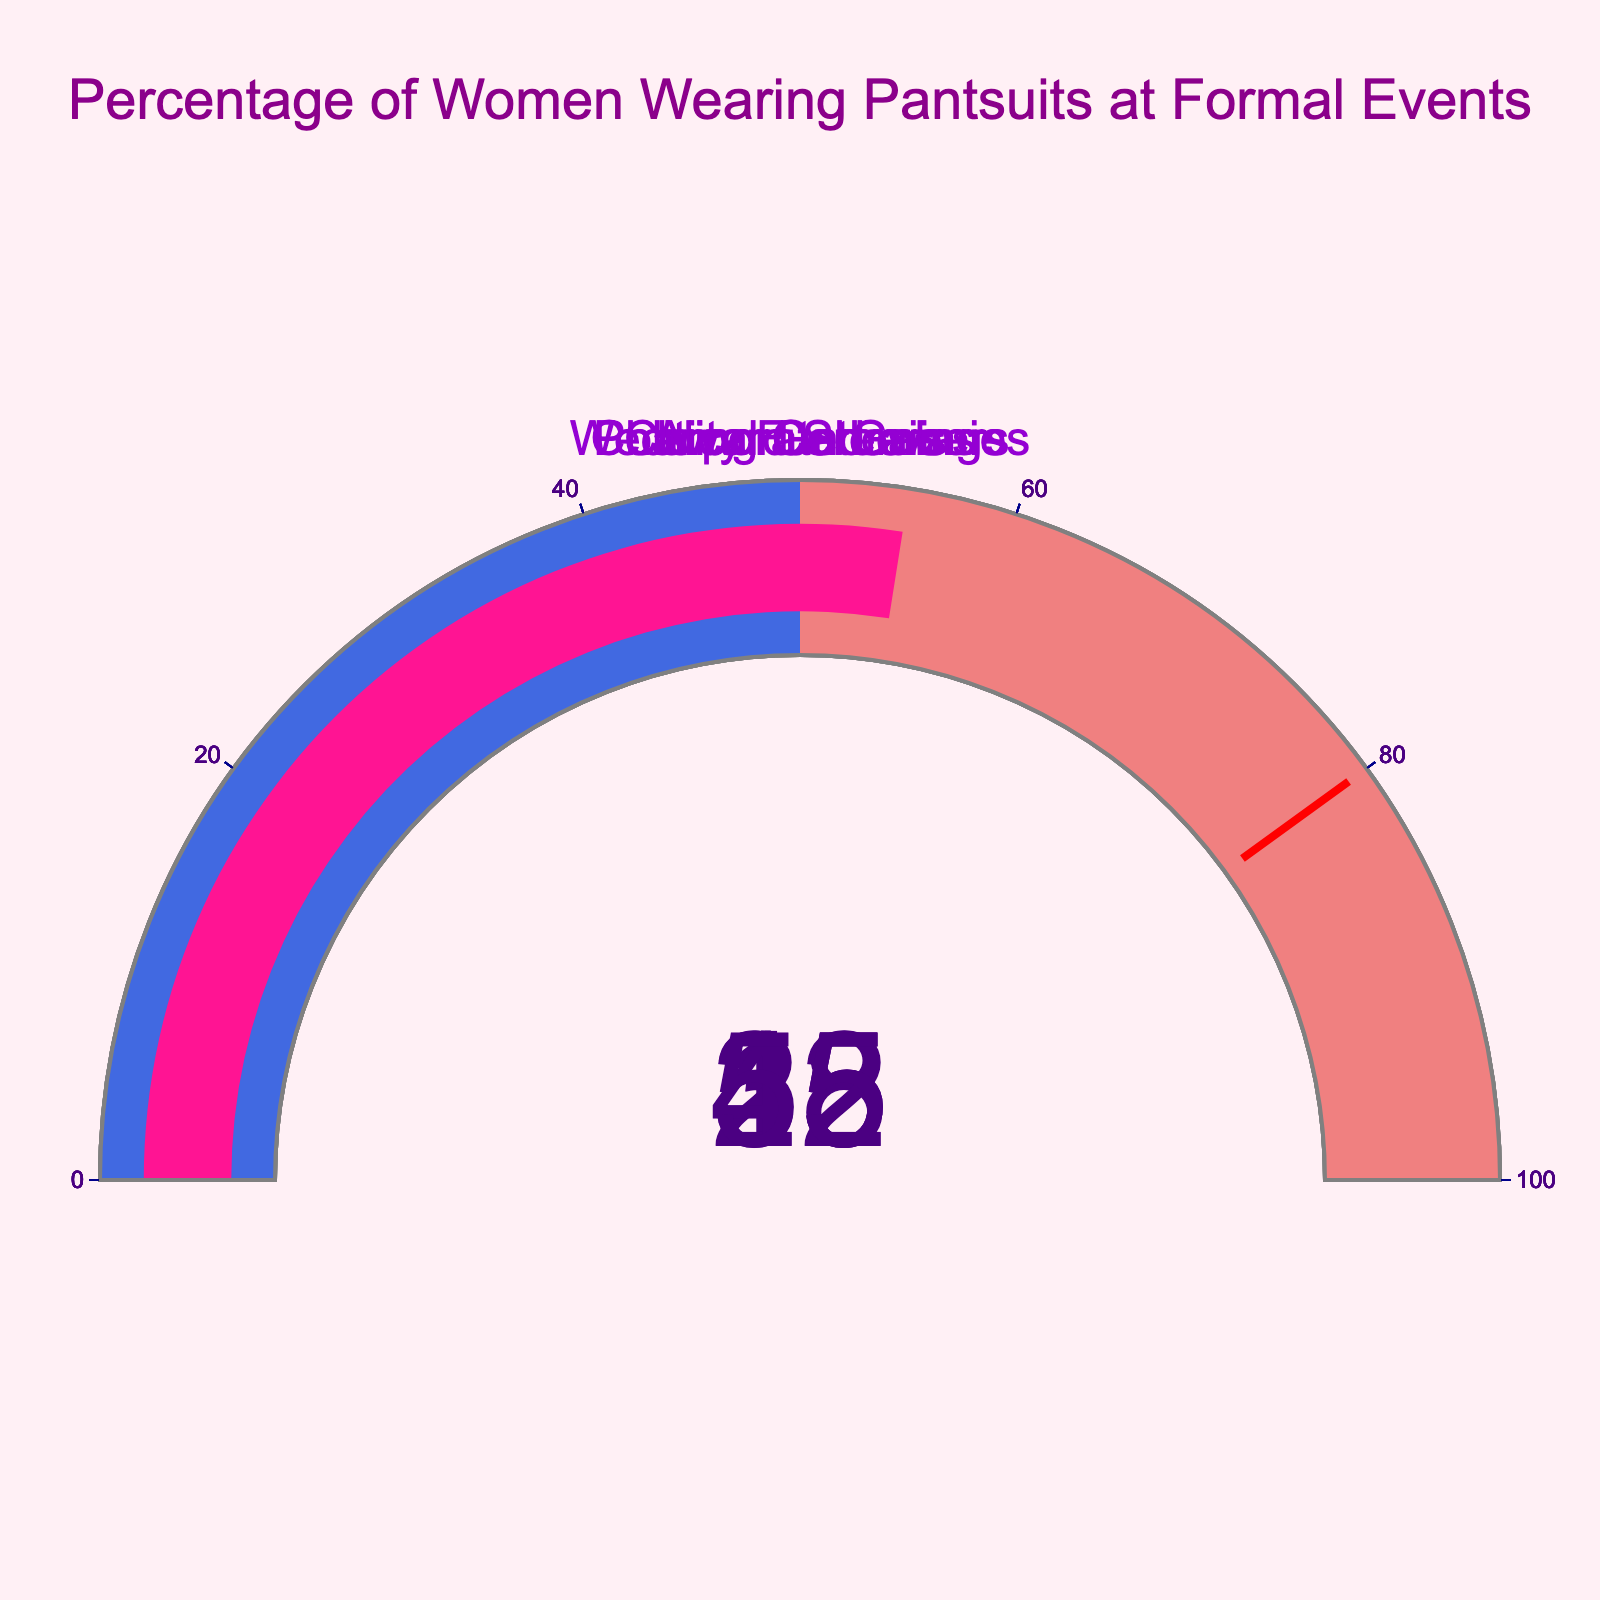What is the title of the figure? The title is located at the top of the chart and it provides a concise description of the entire figure.
Answer: Percentage of Women Wearing Pantsuits at Formal Events How many formal events are displayed in the figure? Each gauge represents a formal event, so counting the number of gauges gives the number of formal events.
Answer: 5 Which event has the highest percentage of women wearing pantsuits? By examining the number on each gauge, it's clear that the political gatherings gauge displays the highest number.
Answer: Political Gatherings What is the percentage of women wearing pantsuits at wedding ceremonies? Refer to the gauge labeled "Wedding Ceremonies" and read the value displayed.
Answer: 15% What is the difference in the percentage of women wearing pantsuits between corporate galas and charity fundraisers? Identify the values for corporate galas (35%) and charity fundraisers (28%) and subtract the latter from the former. 35% - 28% = 7%
Answer: 7% How many events have a percentage of women wearing pantsuits above 30%? Count the gauges where the displayed number is greater than 30.
Answer: 3 What is the average percentage of women wearing pantsuits across all the events? Sum all the percentages and divide by the number of events: (15 + 35 + 28 + 42 + 55) / 5 = 175 / 5 = 35%
Answer: 35% Which event has a higher percentage of women wearing pantsuits, award shows or charity fundraisers? Compare the numbers on the gauges for award shows (42%) and charity fundraisers (28%).
Answer: Award Shows What is the range used for the gauges in the figure? Look at the gauge's axis which indicates a range of numbers. The axis typically ranges from 0 to 100 in such visualizations.
Answer: 0 to 100 